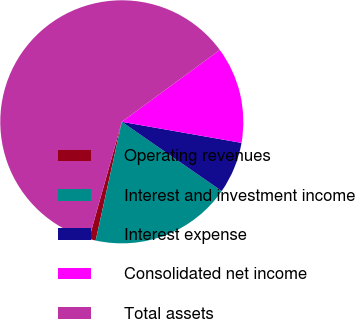<chart> <loc_0><loc_0><loc_500><loc_500><pie_chart><fcel>Operating revenues<fcel>Interest and investment income<fcel>Interest expense<fcel>Consolidated net income<fcel>Total assets<nl><fcel>0.9%<fcel>18.81%<fcel>6.87%<fcel>12.84%<fcel>60.58%<nl></chart> 